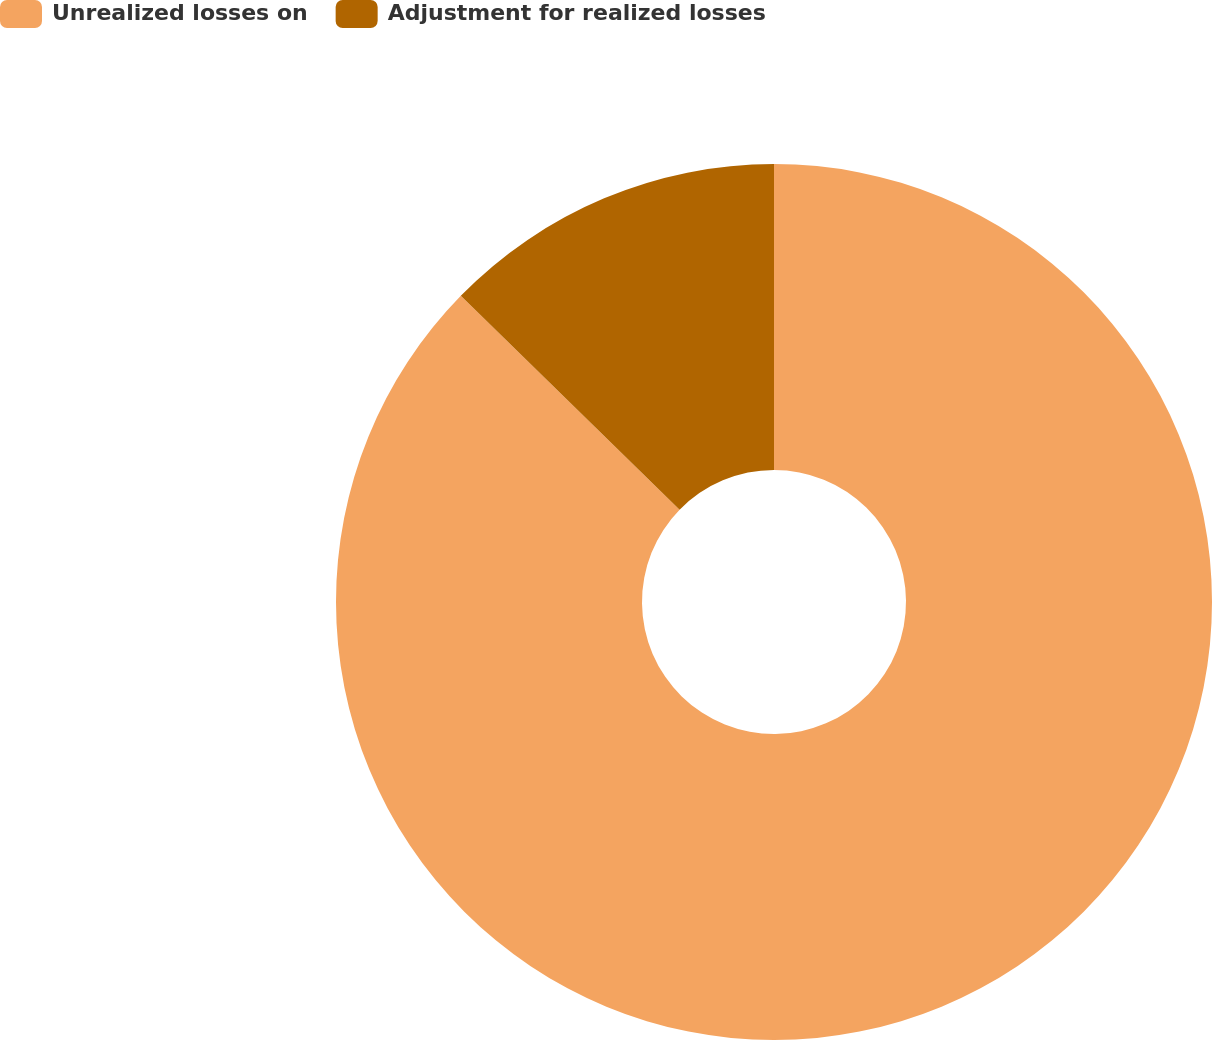Convert chart. <chart><loc_0><loc_0><loc_500><loc_500><pie_chart><fcel>Unrealized losses on<fcel>Adjustment for realized losses<nl><fcel>87.32%<fcel>12.68%<nl></chart> 